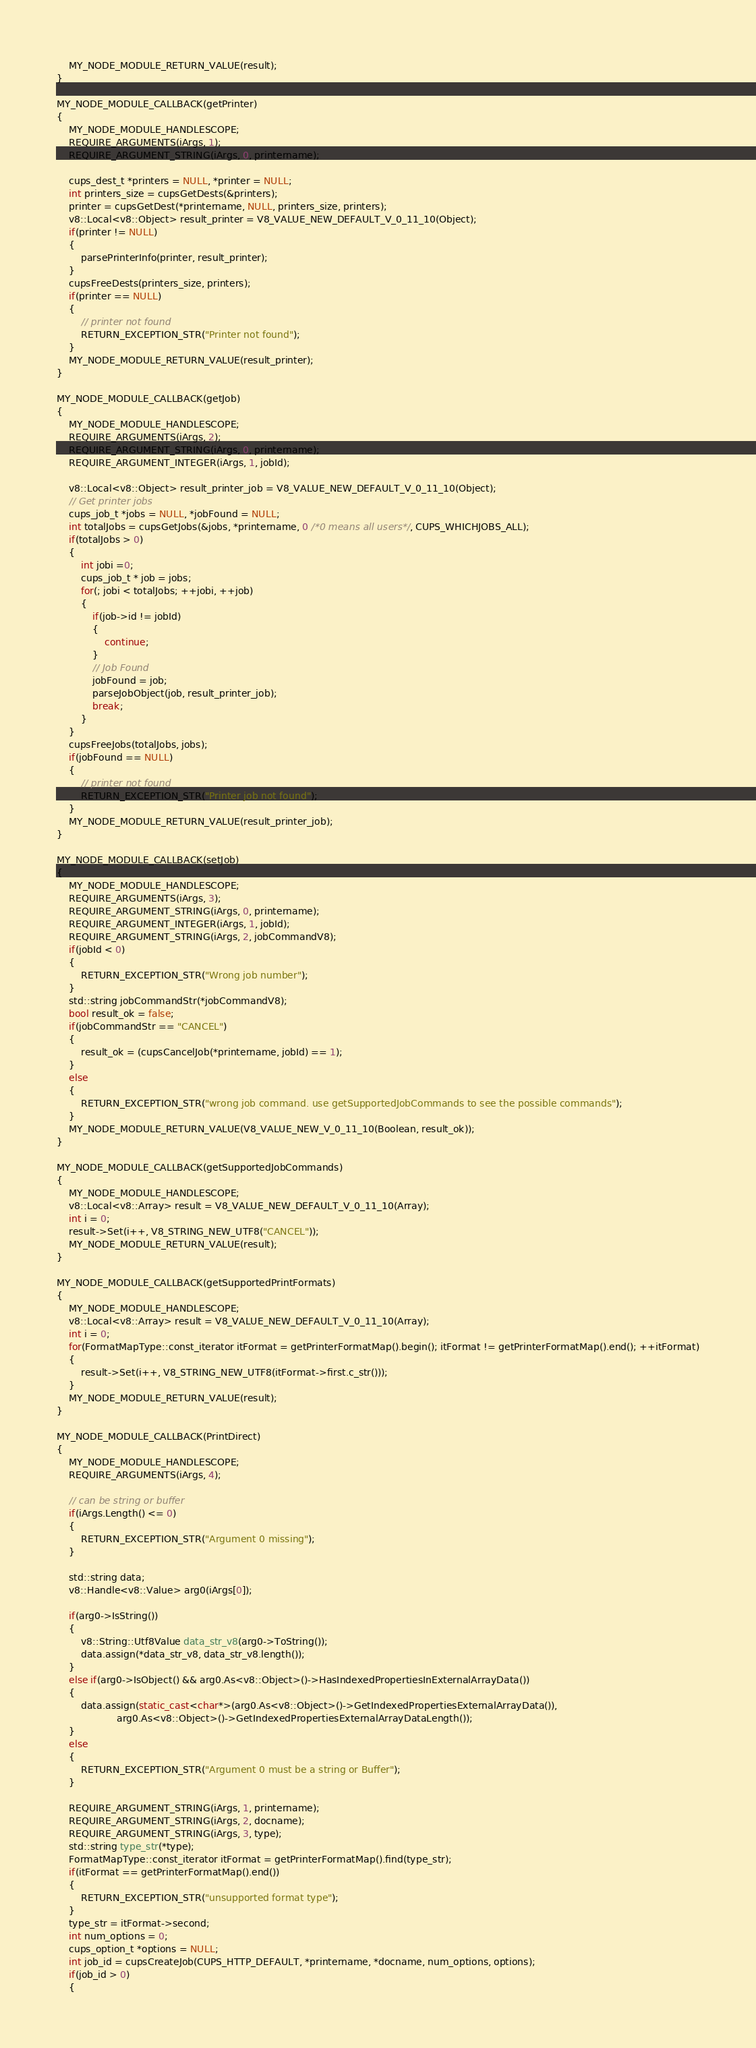Convert code to text. <code><loc_0><loc_0><loc_500><loc_500><_C++_>    MY_NODE_MODULE_RETURN_VALUE(result);
}

MY_NODE_MODULE_CALLBACK(getPrinter)
{
    MY_NODE_MODULE_HANDLESCOPE;
    REQUIRE_ARGUMENTS(iArgs, 1);
    REQUIRE_ARGUMENT_STRING(iArgs, 0, printername);

    cups_dest_t *printers = NULL, *printer = NULL;
    int printers_size = cupsGetDests(&printers);
    printer = cupsGetDest(*printername, NULL, printers_size, printers);
    v8::Local<v8::Object> result_printer = V8_VALUE_NEW_DEFAULT_V_0_11_10(Object);
    if(printer != NULL)
    {
        parsePrinterInfo(printer, result_printer);
    }
    cupsFreeDests(printers_size, printers);
    if(printer == NULL)
    {
        // printer not found
        RETURN_EXCEPTION_STR("Printer not found");
    }
    MY_NODE_MODULE_RETURN_VALUE(result_printer);
}

MY_NODE_MODULE_CALLBACK(getJob)
{
    MY_NODE_MODULE_HANDLESCOPE;
    REQUIRE_ARGUMENTS(iArgs, 2);
    REQUIRE_ARGUMENT_STRING(iArgs, 0, printername);
    REQUIRE_ARGUMENT_INTEGER(iArgs, 1, jobId);

    v8::Local<v8::Object> result_printer_job = V8_VALUE_NEW_DEFAULT_V_0_11_10(Object);
    // Get printer jobs
    cups_job_t *jobs = NULL, *jobFound = NULL;
    int totalJobs = cupsGetJobs(&jobs, *printername, 0 /*0 means all users*/, CUPS_WHICHJOBS_ALL);
    if(totalJobs > 0)
    {
        int jobi =0;
        cups_job_t * job = jobs;
        for(; jobi < totalJobs; ++jobi, ++job)
        {
            if(job->id != jobId)
            {
                continue;
            }
            // Job Found
            jobFound = job;
            parseJobObject(job, result_printer_job);
            break;
        }
    }
    cupsFreeJobs(totalJobs, jobs);
    if(jobFound == NULL)
    {
        // printer not found
        RETURN_EXCEPTION_STR("Printer job not found");
    }
    MY_NODE_MODULE_RETURN_VALUE(result_printer_job);
}

MY_NODE_MODULE_CALLBACK(setJob)
{
    MY_NODE_MODULE_HANDLESCOPE;
    REQUIRE_ARGUMENTS(iArgs, 3);
    REQUIRE_ARGUMENT_STRING(iArgs, 0, printername);
    REQUIRE_ARGUMENT_INTEGER(iArgs, 1, jobId);
    REQUIRE_ARGUMENT_STRING(iArgs, 2, jobCommandV8);
    if(jobId < 0)
    {
        RETURN_EXCEPTION_STR("Wrong job number");
    }
    std::string jobCommandStr(*jobCommandV8);
    bool result_ok = false;
    if(jobCommandStr == "CANCEL")
    {
        result_ok = (cupsCancelJob(*printername, jobId) == 1);
    }
    else
    {
        RETURN_EXCEPTION_STR("wrong job command. use getSupportedJobCommands to see the possible commands");
    }
    MY_NODE_MODULE_RETURN_VALUE(V8_VALUE_NEW_V_0_11_10(Boolean, result_ok));
}

MY_NODE_MODULE_CALLBACK(getSupportedJobCommands)
{
    MY_NODE_MODULE_HANDLESCOPE;
    v8::Local<v8::Array> result = V8_VALUE_NEW_DEFAULT_V_0_11_10(Array);
    int i = 0;
    result->Set(i++, V8_STRING_NEW_UTF8("CANCEL"));
    MY_NODE_MODULE_RETURN_VALUE(result);
}

MY_NODE_MODULE_CALLBACK(getSupportedPrintFormats)
{
    MY_NODE_MODULE_HANDLESCOPE;
    v8::Local<v8::Array> result = V8_VALUE_NEW_DEFAULT_V_0_11_10(Array);
    int i = 0;
    for(FormatMapType::const_iterator itFormat = getPrinterFormatMap().begin(); itFormat != getPrinterFormatMap().end(); ++itFormat)
    {
        result->Set(i++, V8_STRING_NEW_UTF8(itFormat->first.c_str()));
    }
    MY_NODE_MODULE_RETURN_VALUE(result);
}

MY_NODE_MODULE_CALLBACK(PrintDirect)
{
    MY_NODE_MODULE_HANDLESCOPE;
    REQUIRE_ARGUMENTS(iArgs, 4);

    // can be string or buffer
    if(iArgs.Length() <= 0)
    {
        RETURN_EXCEPTION_STR("Argument 0 missing");
    }

    std::string data;
    v8::Handle<v8::Value> arg0(iArgs[0]);

    if(arg0->IsString())
    {
        v8::String::Utf8Value data_str_v8(arg0->ToString());
        data.assign(*data_str_v8, data_str_v8.length());
    }
    else if(arg0->IsObject() && arg0.As<v8::Object>()->HasIndexedPropertiesInExternalArrayData())
    {
        data.assign(static_cast<char*>(arg0.As<v8::Object>()->GetIndexedPropertiesExternalArrayData()),
                    arg0.As<v8::Object>()->GetIndexedPropertiesExternalArrayDataLength());
    }
    else
    {
        RETURN_EXCEPTION_STR("Argument 0 must be a string or Buffer");
    }

    REQUIRE_ARGUMENT_STRING(iArgs, 1, printername);
    REQUIRE_ARGUMENT_STRING(iArgs, 2, docname);
    REQUIRE_ARGUMENT_STRING(iArgs, 3, type);
    std::string type_str(*type);
    FormatMapType::const_iterator itFormat = getPrinterFormatMap().find(type_str);
    if(itFormat == getPrinterFormatMap().end())
    {
        RETURN_EXCEPTION_STR("unsupported format type");
    }
    type_str = itFormat->second;
    int num_options = 0;
    cups_option_t *options = NULL;
    int job_id = cupsCreateJob(CUPS_HTTP_DEFAULT, *printername, *docname, num_options, options);
    if(job_id > 0)
    {</code> 